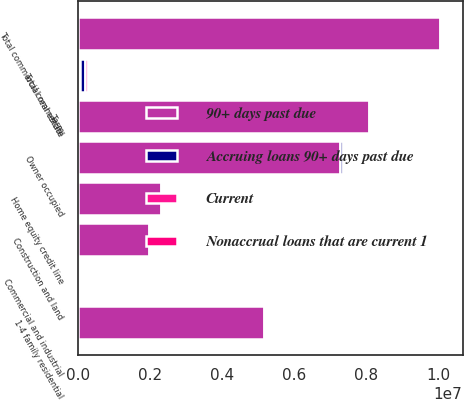Convert chart to OTSL. <chart><loc_0><loc_0><loc_500><loc_500><stacked_bar_chart><ecel><fcel>Commercial and industrial<fcel>Owner occupied<fcel>Total commercial<fcel>Construction and land<fcel>Term<fcel>Total commercial real estate<fcel>Home equity credit line<fcel>1-4 family residential<nl><fcel>90+ days past due<fcel>41332.5<fcel>7.27584e+06<fcel>41332.5<fcel>1.97221e+06<fcel>8.08294e+06<fcel>1.00551e+07<fcel>2.30997e+06<fcel>5.16397e+06<nl><fcel>Nonaccrual loans that are current 1<fcel>28295<fcel>29182<fcel>57702<fcel>2711<fcel>14415<fcel>17126<fcel>4503<fcel>12416<nl><fcel>Current<fcel>41929<fcel>46524<fcel>88478<fcel>11491<fcel>29245<fcel>40736<fcel>6680<fcel>24856<nl><fcel>Accruing loans 90+ days past due<fcel>70224<fcel>75706<fcel>146180<fcel>14202<fcel>43660<fcel>57862<fcel>11183<fcel>37272<nl></chart> 